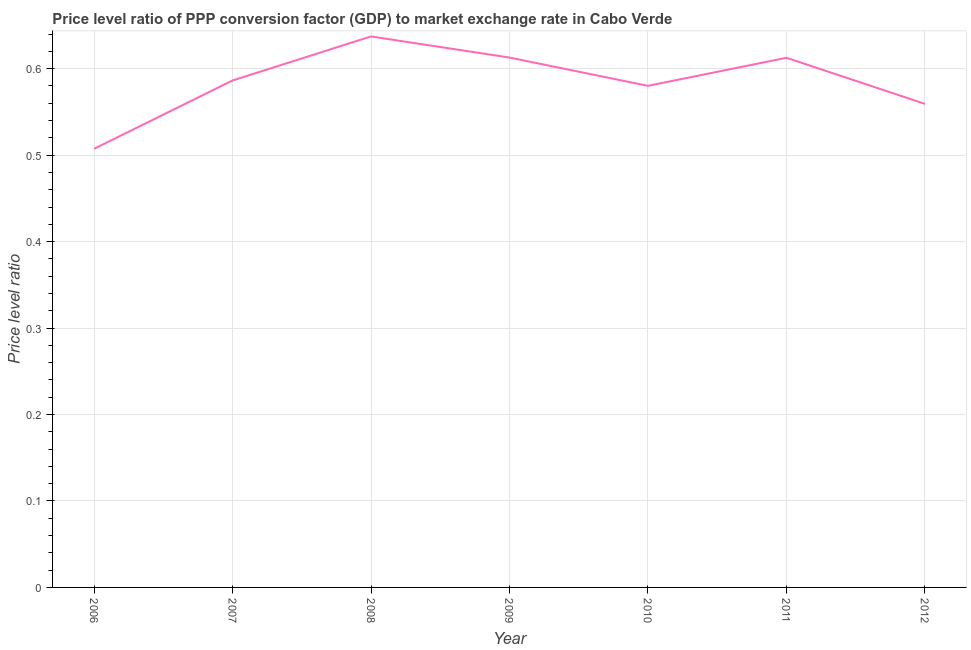What is the price level ratio in 2010?
Ensure brevity in your answer.  0.58. Across all years, what is the maximum price level ratio?
Provide a succinct answer. 0.64. Across all years, what is the minimum price level ratio?
Keep it short and to the point. 0.51. In which year was the price level ratio minimum?
Make the answer very short. 2006. What is the sum of the price level ratio?
Ensure brevity in your answer.  4.1. What is the difference between the price level ratio in 2008 and 2009?
Your answer should be very brief. 0.02. What is the average price level ratio per year?
Your response must be concise. 0.59. What is the median price level ratio?
Give a very brief answer. 0.59. Do a majority of the years between 2009 and 2011 (inclusive) have price level ratio greater than 0.42000000000000004 ?
Ensure brevity in your answer.  Yes. What is the ratio of the price level ratio in 2009 to that in 2012?
Provide a succinct answer. 1.1. What is the difference between the highest and the second highest price level ratio?
Make the answer very short. 0.02. Is the sum of the price level ratio in 2007 and 2012 greater than the maximum price level ratio across all years?
Provide a succinct answer. Yes. What is the difference between the highest and the lowest price level ratio?
Offer a terse response. 0.13. In how many years, is the price level ratio greater than the average price level ratio taken over all years?
Provide a succinct answer. 4. Does the price level ratio monotonically increase over the years?
Your answer should be compact. No. How many years are there in the graph?
Your response must be concise. 7. Are the values on the major ticks of Y-axis written in scientific E-notation?
Keep it short and to the point. No. Does the graph contain grids?
Your answer should be compact. Yes. What is the title of the graph?
Keep it short and to the point. Price level ratio of PPP conversion factor (GDP) to market exchange rate in Cabo Verde. What is the label or title of the X-axis?
Offer a very short reply. Year. What is the label or title of the Y-axis?
Offer a very short reply. Price level ratio. What is the Price level ratio of 2006?
Provide a short and direct response. 0.51. What is the Price level ratio in 2007?
Your answer should be very brief. 0.59. What is the Price level ratio of 2008?
Keep it short and to the point. 0.64. What is the Price level ratio in 2009?
Offer a terse response. 0.61. What is the Price level ratio in 2010?
Provide a succinct answer. 0.58. What is the Price level ratio of 2011?
Ensure brevity in your answer.  0.61. What is the Price level ratio in 2012?
Your answer should be compact. 0.56. What is the difference between the Price level ratio in 2006 and 2007?
Provide a short and direct response. -0.08. What is the difference between the Price level ratio in 2006 and 2008?
Provide a succinct answer. -0.13. What is the difference between the Price level ratio in 2006 and 2009?
Your response must be concise. -0.11. What is the difference between the Price level ratio in 2006 and 2010?
Provide a short and direct response. -0.07. What is the difference between the Price level ratio in 2006 and 2011?
Make the answer very short. -0.11. What is the difference between the Price level ratio in 2006 and 2012?
Give a very brief answer. -0.05. What is the difference between the Price level ratio in 2007 and 2008?
Keep it short and to the point. -0.05. What is the difference between the Price level ratio in 2007 and 2009?
Offer a terse response. -0.03. What is the difference between the Price level ratio in 2007 and 2010?
Ensure brevity in your answer.  0.01. What is the difference between the Price level ratio in 2007 and 2011?
Ensure brevity in your answer.  -0.03. What is the difference between the Price level ratio in 2007 and 2012?
Give a very brief answer. 0.03. What is the difference between the Price level ratio in 2008 and 2009?
Provide a succinct answer. 0.02. What is the difference between the Price level ratio in 2008 and 2010?
Make the answer very short. 0.06. What is the difference between the Price level ratio in 2008 and 2011?
Your response must be concise. 0.02. What is the difference between the Price level ratio in 2008 and 2012?
Make the answer very short. 0.08. What is the difference between the Price level ratio in 2009 and 2010?
Offer a very short reply. 0.03. What is the difference between the Price level ratio in 2009 and 2011?
Provide a short and direct response. 0. What is the difference between the Price level ratio in 2009 and 2012?
Provide a succinct answer. 0.05. What is the difference between the Price level ratio in 2010 and 2011?
Your answer should be compact. -0.03. What is the difference between the Price level ratio in 2010 and 2012?
Keep it short and to the point. 0.02. What is the difference between the Price level ratio in 2011 and 2012?
Provide a short and direct response. 0.05. What is the ratio of the Price level ratio in 2006 to that in 2007?
Your response must be concise. 0.86. What is the ratio of the Price level ratio in 2006 to that in 2008?
Offer a terse response. 0.8. What is the ratio of the Price level ratio in 2006 to that in 2009?
Your response must be concise. 0.83. What is the ratio of the Price level ratio in 2006 to that in 2010?
Your answer should be compact. 0.87. What is the ratio of the Price level ratio in 2006 to that in 2011?
Make the answer very short. 0.83. What is the ratio of the Price level ratio in 2006 to that in 2012?
Offer a very short reply. 0.91. What is the ratio of the Price level ratio in 2007 to that in 2009?
Make the answer very short. 0.96. What is the ratio of the Price level ratio in 2007 to that in 2011?
Your response must be concise. 0.96. What is the ratio of the Price level ratio in 2007 to that in 2012?
Make the answer very short. 1.05. What is the ratio of the Price level ratio in 2008 to that in 2010?
Offer a very short reply. 1.1. What is the ratio of the Price level ratio in 2008 to that in 2012?
Provide a short and direct response. 1.14. What is the ratio of the Price level ratio in 2009 to that in 2010?
Your response must be concise. 1.06. What is the ratio of the Price level ratio in 2009 to that in 2012?
Provide a short and direct response. 1.1. What is the ratio of the Price level ratio in 2010 to that in 2011?
Provide a succinct answer. 0.95. What is the ratio of the Price level ratio in 2010 to that in 2012?
Make the answer very short. 1.04. What is the ratio of the Price level ratio in 2011 to that in 2012?
Offer a terse response. 1.09. 